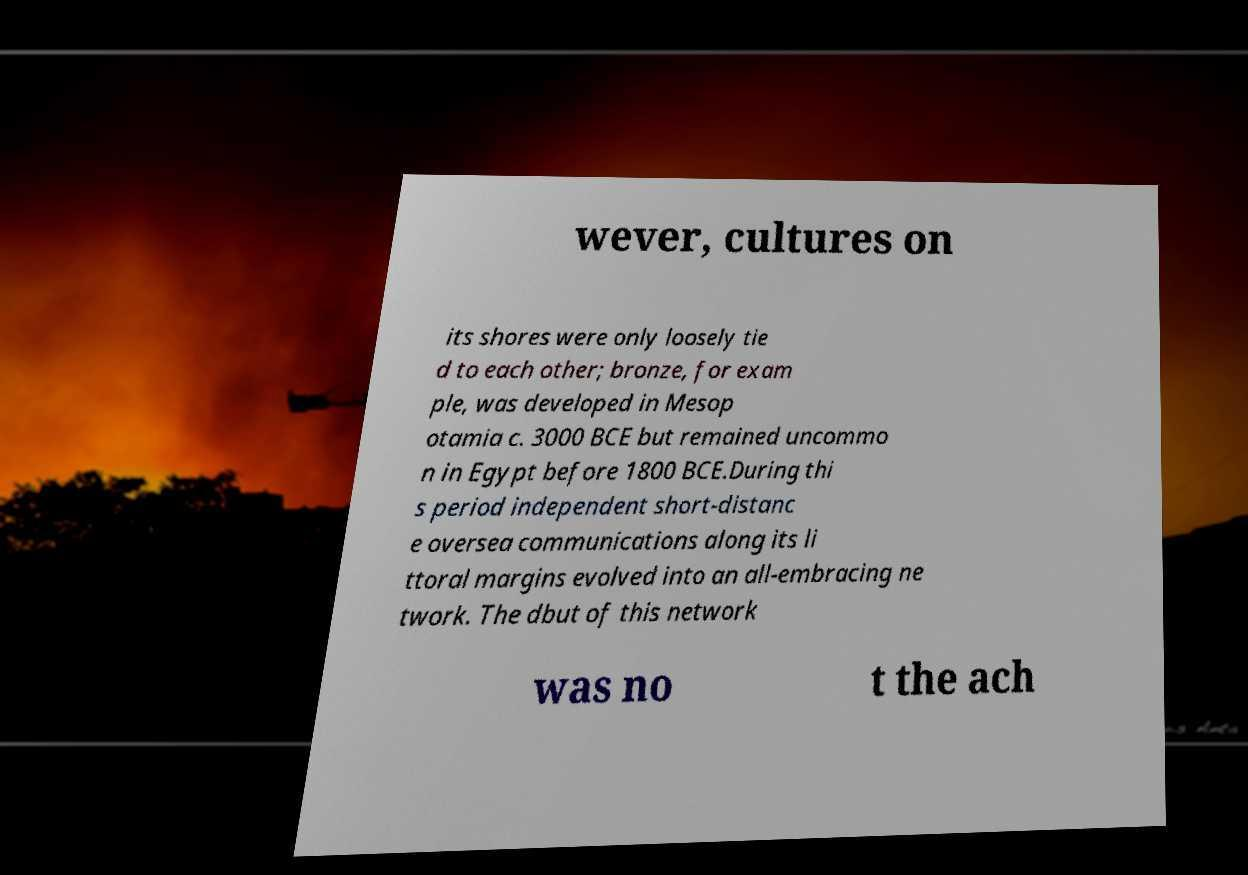Could you assist in decoding the text presented in this image and type it out clearly? wever, cultures on its shores were only loosely tie d to each other; bronze, for exam ple, was developed in Mesop otamia c. 3000 BCE but remained uncommo n in Egypt before 1800 BCE.During thi s period independent short-distanc e oversea communications along its li ttoral margins evolved into an all-embracing ne twork. The dbut of this network was no t the ach 